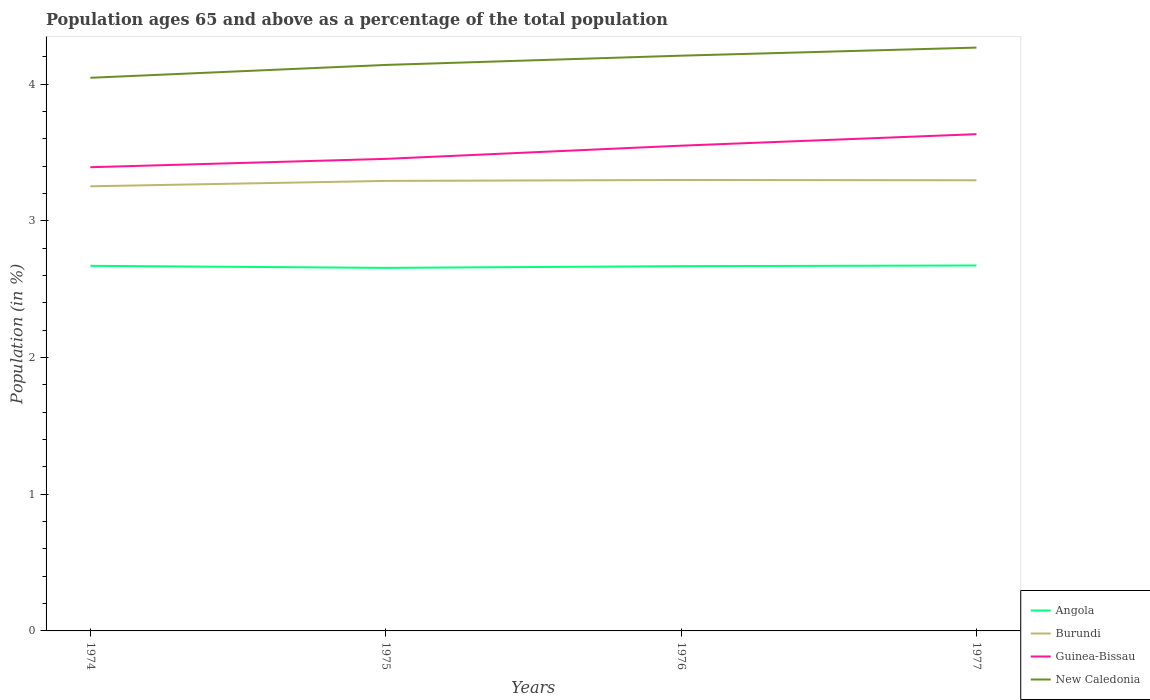Is the number of lines equal to the number of legend labels?
Offer a very short reply. Yes. Across all years, what is the maximum percentage of the population ages 65 and above in Guinea-Bissau?
Ensure brevity in your answer.  3.39. In which year was the percentage of the population ages 65 and above in Burundi maximum?
Keep it short and to the point. 1974. What is the total percentage of the population ages 65 and above in New Caledonia in the graph?
Provide a short and direct response. -0.06. What is the difference between the highest and the second highest percentage of the population ages 65 and above in Guinea-Bissau?
Your answer should be compact. 0.24. Is the percentage of the population ages 65 and above in Guinea-Bissau strictly greater than the percentage of the population ages 65 and above in Burundi over the years?
Your response must be concise. No. How many years are there in the graph?
Keep it short and to the point. 4. Are the values on the major ticks of Y-axis written in scientific E-notation?
Give a very brief answer. No. How are the legend labels stacked?
Make the answer very short. Vertical. What is the title of the graph?
Your answer should be compact. Population ages 65 and above as a percentage of the total population. What is the label or title of the X-axis?
Ensure brevity in your answer.  Years. What is the label or title of the Y-axis?
Keep it short and to the point. Population (in %). What is the Population (in %) of Angola in 1974?
Give a very brief answer. 2.67. What is the Population (in %) of Burundi in 1974?
Make the answer very short. 3.25. What is the Population (in %) of Guinea-Bissau in 1974?
Your response must be concise. 3.39. What is the Population (in %) of New Caledonia in 1974?
Your response must be concise. 4.05. What is the Population (in %) in Angola in 1975?
Provide a short and direct response. 2.66. What is the Population (in %) of Burundi in 1975?
Your answer should be compact. 3.29. What is the Population (in %) in Guinea-Bissau in 1975?
Your answer should be very brief. 3.45. What is the Population (in %) of New Caledonia in 1975?
Provide a short and direct response. 4.14. What is the Population (in %) of Angola in 1976?
Offer a terse response. 2.67. What is the Population (in %) in Burundi in 1976?
Provide a short and direct response. 3.3. What is the Population (in %) of Guinea-Bissau in 1976?
Make the answer very short. 3.55. What is the Population (in %) of New Caledonia in 1976?
Offer a very short reply. 4.21. What is the Population (in %) in Angola in 1977?
Your answer should be very brief. 2.67. What is the Population (in %) of Burundi in 1977?
Make the answer very short. 3.3. What is the Population (in %) in Guinea-Bissau in 1977?
Ensure brevity in your answer.  3.63. What is the Population (in %) of New Caledonia in 1977?
Your answer should be very brief. 4.27. Across all years, what is the maximum Population (in %) in Angola?
Make the answer very short. 2.67. Across all years, what is the maximum Population (in %) in Burundi?
Your response must be concise. 3.3. Across all years, what is the maximum Population (in %) of Guinea-Bissau?
Your answer should be compact. 3.63. Across all years, what is the maximum Population (in %) in New Caledonia?
Give a very brief answer. 4.27. Across all years, what is the minimum Population (in %) in Angola?
Your answer should be compact. 2.66. Across all years, what is the minimum Population (in %) of Burundi?
Provide a short and direct response. 3.25. Across all years, what is the minimum Population (in %) in Guinea-Bissau?
Provide a short and direct response. 3.39. Across all years, what is the minimum Population (in %) in New Caledonia?
Your answer should be very brief. 4.05. What is the total Population (in %) in Angola in the graph?
Offer a terse response. 10.67. What is the total Population (in %) of Burundi in the graph?
Offer a very short reply. 13.14. What is the total Population (in %) in Guinea-Bissau in the graph?
Give a very brief answer. 14.03. What is the total Population (in %) in New Caledonia in the graph?
Ensure brevity in your answer.  16.67. What is the difference between the Population (in %) in Angola in 1974 and that in 1975?
Provide a succinct answer. 0.02. What is the difference between the Population (in %) of Burundi in 1974 and that in 1975?
Your response must be concise. -0.04. What is the difference between the Population (in %) in Guinea-Bissau in 1974 and that in 1975?
Provide a succinct answer. -0.06. What is the difference between the Population (in %) in New Caledonia in 1974 and that in 1975?
Provide a short and direct response. -0.09. What is the difference between the Population (in %) in Angola in 1974 and that in 1976?
Ensure brevity in your answer.  0. What is the difference between the Population (in %) of Burundi in 1974 and that in 1976?
Offer a very short reply. -0.05. What is the difference between the Population (in %) of Guinea-Bissau in 1974 and that in 1976?
Offer a terse response. -0.16. What is the difference between the Population (in %) in New Caledonia in 1974 and that in 1976?
Keep it short and to the point. -0.16. What is the difference between the Population (in %) of Angola in 1974 and that in 1977?
Your response must be concise. -0. What is the difference between the Population (in %) in Burundi in 1974 and that in 1977?
Make the answer very short. -0.04. What is the difference between the Population (in %) of Guinea-Bissau in 1974 and that in 1977?
Offer a very short reply. -0.24. What is the difference between the Population (in %) in New Caledonia in 1974 and that in 1977?
Provide a succinct answer. -0.22. What is the difference between the Population (in %) of Angola in 1975 and that in 1976?
Make the answer very short. -0.01. What is the difference between the Population (in %) of Burundi in 1975 and that in 1976?
Your answer should be compact. -0.01. What is the difference between the Population (in %) of Guinea-Bissau in 1975 and that in 1976?
Offer a very short reply. -0.1. What is the difference between the Population (in %) in New Caledonia in 1975 and that in 1976?
Offer a terse response. -0.07. What is the difference between the Population (in %) of Angola in 1975 and that in 1977?
Give a very brief answer. -0.02. What is the difference between the Population (in %) of Burundi in 1975 and that in 1977?
Provide a succinct answer. -0. What is the difference between the Population (in %) in Guinea-Bissau in 1975 and that in 1977?
Your answer should be very brief. -0.18. What is the difference between the Population (in %) of New Caledonia in 1975 and that in 1977?
Offer a terse response. -0.13. What is the difference between the Population (in %) in Angola in 1976 and that in 1977?
Provide a succinct answer. -0. What is the difference between the Population (in %) in Burundi in 1976 and that in 1977?
Make the answer very short. 0. What is the difference between the Population (in %) in Guinea-Bissau in 1976 and that in 1977?
Give a very brief answer. -0.08. What is the difference between the Population (in %) of New Caledonia in 1976 and that in 1977?
Make the answer very short. -0.06. What is the difference between the Population (in %) in Angola in 1974 and the Population (in %) in Burundi in 1975?
Your response must be concise. -0.62. What is the difference between the Population (in %) of Angola in 1974 and the Population (in %) of Guinea-Bissau in 1975?
Offer a very short reply. -0.78. What is the difference between the Population (in %) of Angola in 1974 and the Population (in %) of New Caledonia in 1975?
Give a very brief answer. -1.47. What is the difference between the Population (in %) of Burundi in 1974 and the Population (in %) of Guinea-Bissau in 1975?
Your response must be concise. -0.2. What is the difference between the Population (in %) in Burundi in 1974 and the Population (in %) in New Caledonia in 1975?
Make the answer very short. -0.89. What is the difference between the Population (in %) of Guinea-Bissau in 1974 and the Population (in %) of New Caledonia in 1975?
Make the answer very short. -0.75. What is the difference between the Population (in %) of Angola in 1974 and the Population (in %) of Burundi in 1976?
Offer a terse response. -0.63. What is the difference between the Population (in %) in Angola in 1974 and the Population (in %) in Guinea-Bissau in 1976?
Keep it short and to the point. -0.88. What is the difference between the Population (in %) in Angola in 1974 and the Population (in %) in New Caledonia in 1976?
Offer a very short reply. -1.54. What is the difference between the Population (in %) of Burundi in 1974 and the Population (in %) of Guinea-Bissau in 1976?
Provide a succinct answer. -0.3. What is the difference between the Population (in %) in Burundi in 1974 and the Population (in %) in New Caledonia in 1976?
Your response must be concise. -0.96. What is the difference between the Population (in %) of Guinea-Bissau in 1974 and the Population (in %) of New Caledonia in 1976?
Ensure brevity in your answer.  -0.82. What is the difference between the Population (in %) in Angola in 1974 and the Population (in %) in Burundi in 1977?
Ensure brevity in your answer.  -0.63. What is the difference between the Population (in %) of Angola in 1974 and the Population (in %) of Guinea-Bissau in 1977?
Your answer should be very brief. -0.96. What is the difference between the Population (in %) in Angola in 1974 and the Population (in %) in New Caledonia in 1977?
Keep it short and to the point. -1.6. What is the difference between the Population (in %) in Burundi in 1974 and the Population (in %) in Guinea-Bissau in 1977?
Make the answer very short. -0.38. What is the difference between the Population (in %) of Burundi in 1974 and the Population (in %) of New Caledonia in 1977?
Keep it short and to the point. -1.01. What is the difference between the Population (in %) in Guinea-Bissau in 1974 and the Population (in %) in New Caledonia in 1977?
Your answer should be very brief. -0.88. What is the difference between the Population (in %) of Angola in 1975 and the Population (in %) of Burundi in 1976?
Provide a short and direct response. -0.64. What is the difference between the Population (in %) of Angola in 1975 and the Population (in %) of Guinea-Bissau in 1976?
Give a very brief answer. -0.89. What is the difference between the Population (in %) in Angola in 1975 and the Population (in %) in New Caledonia in 1976?
Ensure brevity in your answer.  -1.55. What is the difference between the Population (in %) of Burundi in 1975 and the Population (in %) of Guinea-Bissau in 1976?
Offer a very short reply. -0.26. What is the difference between the Population (in %) in Burundi in 1975 and the Population (in %) in New Caledonia in 1976?
Offer a very short reply. -0.92. What is the difference between the Population (in %) in Guinea-Bissau in 1975 and the Population (in %) in New Caledonia in 1976?
Offer a very short reply. -0.76. What is the difference between the Population (in %) in Angola in 1975 and the Population (in %) in Burundi in 1977?
Give a very brief answer. -0.64. What is the difference between the Population (in %) in Angola in 1975 and the Population (in %) in Guinea-Bissau in 1977?
Ensure brevity in your answer.  -0.98. What is the difference between the Population (in %) in Angola in 1975 and the Population (in %) in New Caledonia in 1977?
Offer a very short reply. -1.61. What is the difference between the Population (in %) in Burundi in 1975 and the Population (in %) in Guinea-Bissau in 1977?
Your answer should be compact. -0.34. What is the difference between the Population (in %) of Burundi in 1975 and the Population (in %) of New Caledonia in 1977?
Offer a very short reply. -0.98. What is the difference between the Population (in %) of Guinea-Bissau in 1975 and the Population (in %) of New Caledonia in 1977?
Offer a very short reply. -0.81. What is the difference between the Population (in %) of Angola in 1976 and the Population (in %) of Burundi in 1977?
Your answer should be compact. -0.63. What is the difference between the Population (in %) of Angola in 1976 and the Population (in %) of Guinea-Bissau in 1977?
Offer a very short reply. -0.97. What is the difference between the Population (in %) in Angola in 1976 and the Population (in %) in New Caledonia in 1977?
Provide a short and direct response. -1.6. What is the difference between the Population (in %) of Burundi in 1976 and the Population (in %) of Guinea-Bissau in 1977?
Offer a very short reply. -0.34. What is the difference between the Population (in %) of Burundi in 1976 and the Population (in %) of New Caledonia in 1977?
Make the answer very short. -0.97. What is the difference between the Population (in %) of Guinea-Bissau in 1976 and the Population (in %) of New Caledonia in 1977?
Ensure brevity in your answer.  -0.72. What is the average Population (in %) of Angola per year?
Your answer should be very brief. 2.67. What is the average Population (in %) in Burundi per year?
Give a very brief answer. 3.29. What is the average Population (in %) of Guinea-Bissau per year?
Give a very brief answer. 3.51. What is the average Population (in %) of New Caledonia per year?
Ensure brevity in your answer.  4.17. In the year 1974, what is the difference between the Population (in %) of Angola and Population (in %) of Burundi?
Provide a succinct answer. -0.58. In the year 1974, what is the difference between the Population (in %) in Angola and Population (in %) in Guinea-Bissau?
Offer a very short reply. -0.72. In the year 1974, what is the difference between the Population (in %) in Angola and Population (in %) in New Caledonia?
Keep it short and to the point. -1.38. In the year 1974, what is the difference between the Population (in %) in Burundi and Population (in %) in Guinea-Bissau?
Your answer should be compact. -0.14. In the year 1974, what is the difference between the Population (in %) in Burundi and Population (in %) in New Caledonia?
Offer a very short reply. -0.79. In the year 1974, what is the difference between the Population (in %) of Guinea-Bissau and Population (in %) of New Caledonia?
Provide a succinct answer. -0.65. In the year 1975, what is the difference between the Population (in %) in Angola and Population (in %) in Burundi?
Give a very brief answer. -0.64. In the year 1975, what is the difference between the Population (in %) of Angola and Population (in %) of Guinea-Bissau?
Offer a terse response. -0.8. In the year 1975, what is the difference between the Population (in %) of Angola and Population (in %) of New Caledonia?
Give a very brief answer. -1.48. In the year 1975, what is the difference between the Population (in %) of Burundi and Population (in %) of Guinea-Bissau?
Keep it short and to the point. -0.16. In the year 1975, what is the difference between the Population (in %) of Burundi and Population (in %) of New Caledonia?
Offer a very short reply. -0.85. In the year 1975, what is the difference between the Population (in %) in Guinea-Bissau and Population (in %) in New Caledonia?
Ensure brevity in your answer.  -0.69. In the year 1976, what is the difference between the Population (in %) in Angola and Population (in %) in Burundi?
Your response must be concise. -0.63. In the year 1976, what is the difference between the Population (in %) in Angola and Population (in %) in Guinea-Bissau?
Provide a succinct answer. -0.88. In the year 1976, what is the difference between the Population (in %) of Angola and Population (in %) of New Caledonia?
Offer a terse response. -1.54. In the year 1976, what is the difference between the Population (in %) of Burundi and Population (in %) of Guinea-Bissau?
Keep it short and to the point. -0.25. In the year 1976, what is the difference between the Population (in %) of Burundi and Population (in %) of New Caledonia?
Ensure brevity in your answer.  -0.91. In the year 1976, what is the difference between the Population (in %) of Guinea-Bissau and Population (in %) of New Caledonia?
Provide a short and direct response. -0.66. In the year 1977, what is the difference between the Population (in %) of Angola and Population (in %) of Burundi?
Your answer should be compact. -0.62. In the year 1977, what is the difference between the Population (in %) of Angola and Population (in %) of Guinea-Bissau?
Your response must be concise. -0.96. In the year 1977, what is the difference between the Population (in %) in Angola and Population (in %) in New Caledonia?
Provide a short and direct response. -1.59. In the year 1977, what is the difference between the Population (in %) of Burundi and Population (in %) of Guinea-Bissau?
Provide a short and direct response. -0.34. In the year 1977, what is the difference between the Population (in %) in Burundi and Population (in %) in New Caledonia?
Offer a terse response. -0.97. In the year 1977, what is the difference between the Population (in %) of Guinea-Bissau and Population (in %) of New Caledonia?
Your answer should be compact. -0.63. What is the ratio of the Population (in %) in Angola in 1974 to that in 1975?
Make the answer very short. 1.01. What is the ratio of the Population (in %) of Burundi in 1974 to that in 1975?
Offer a very short reply. 0.99. What is the ratio of the Population (in %) of Guinea-Bissau in 1974 to that in 1975?
Keep it short and to the point. 0.98. What is the ratio of the Population (in %) of New Caledonia in 1974 to that in 1975?
Your answer should be very brief. 0.98. What is the ratio of the Population (in %) in Burundi in 1974 to that in 1976?
Your response must be concise. 0.99. What is the ratio of the Population (in %) in Guinea-Bissau in 1974 to that in 1976?
Provide a short and direct response. 0.96. What is the ratio of the Population (in %) in New Caledonia in 1974 to that in 1976?
Ensure brevity in your answer.  0.96. What is the ratio of the Population (in %) of Burundi in 1974 to that in 1977?
Your response must be concise. 0.99. What is the ratio of the Population (in %) in Guinea-Bissau in 1974 to that in 1977?
Make the answer very short. 0.93. What is the ratio of the Population (in %) of New Caledonia in 1974 to that in 1977?
Your response must be concise. 0.95. What is the ratio of the Population (in %) in Guinea-Bissau in 1975 to that in 1976?
Ensure brevity in your answer.  0.97. What is the ratio of the Population (in %) in New Caledonia in 1975 to that in 1976?
Give a very brief answer. 0.98. What is the ratio of the Population (in %) of Burundi in 1975 to that in 1977?
Offer a terse response. 1. What is the ratio of the Population (in %) of Guinea-Bissau in 1975 to that in 1977?
Ensure brevity in your answer.  0.95. What is the ratio of the Population (in %) of New Caledonia in 1975 to that in 1977?
Give a very brief answer. 0.97. What is the ratio of the Population (in %) in Angola in 1976 to that in 1977?
Offer a terse response. 1. What is the ratio of the Population (in %) of Guinea-Bissau in 1976 to that in 1977?
Your answer should be very brief. 0.98. What is the ratio of the Population (in %) in New Caledonia in 1976 to that in 1977?
Your response must be concise. 0.99. What is the difference between the highest and the second highest Population (in %) of Angola?
Give a very brief answer. 0. What is the difference between the highest and the second highest Population (in %) in Burundi?
Your answer should be compact. 0. What is the difference between the highest and the second highest Population (in %) in Guinea-Bissau?
Keep it short and to the point. 0.08. What is the difference between the highest and the second highest Population (in %) of New Caledonia?
Ensure brevity in your answer.  0.06. What is the difference between the highest and the lowest Population (in %) of Angola?
Your answer should be very brief. 0.02. What is the difference between the highest and the lowest Population (in %) of Burundi?
Your answer should be compact. 0.05. What is the difference between the highest and the lowest Population (in %) of Guinea-Bissau?
Keep it short and to the point. 0.24. What is the difference between the highest and the lowest Population (in %) in New Caledonia?
Offer a very short reply. 0.22. 